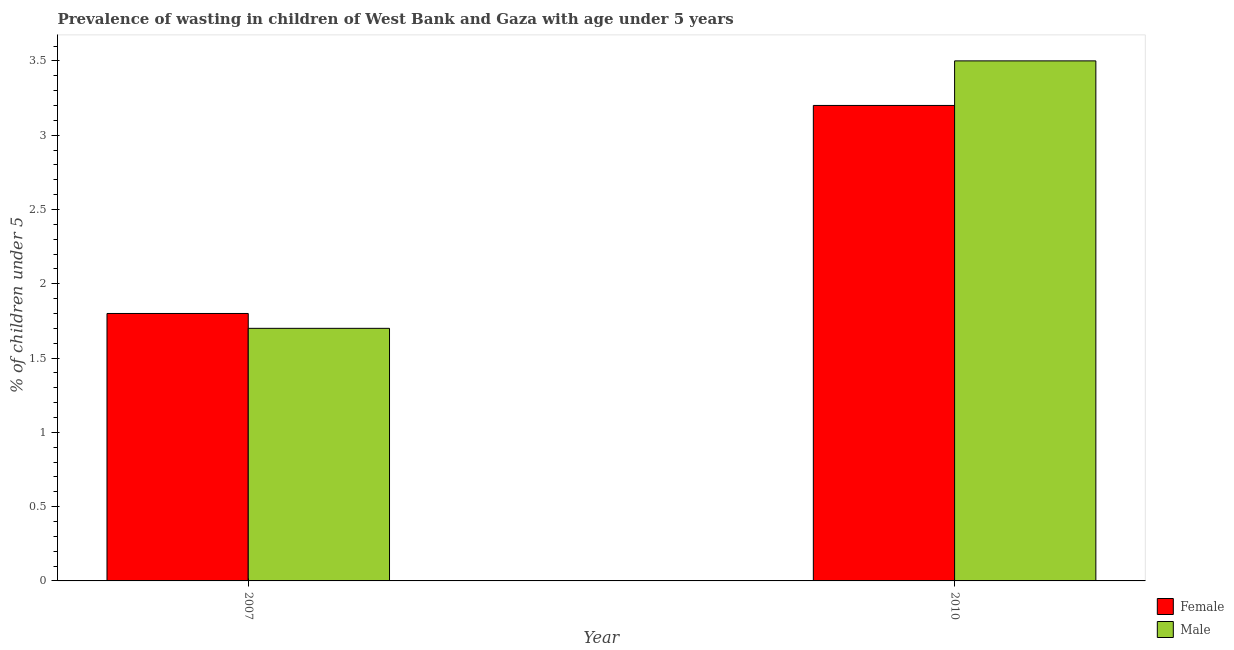How many groups of bars are there?
Your answer should be compact. 2. Are the number of bars per tick equal to the number of legend labels?
Provide a short and direct response. Yes. In how many cases, is the number of bars for a given year not equal to the number of legend labels?
Ensure brevity in your answer.  0. What is the percentage of undernourished male children in 2007?
Give a very brief answer. 1.7. Across all years, what is the maximum percentage of undernourished female children?
Your answer should be very brief. 3.2. Across all years, what is the minimum percentage of undernourished female children?
Offer a very short reply. 1.8. In which year was the percentage of undernourished female children maximum?
Your answer should be compact. 2010. In which year was the percentage of undernourished female children minimum?
Your response must be concise. 2007. What is the total percentage of undernourished male children in the graph?
Your answer should be very brief. 5.2. What is the difference between the percentage of undernourished female children in 2007 and that in 2010?
Ensure brevity in your answer.  -1.4. What is the difference between the percentage of undernourished female children in 2010 and the percentage of undernourished male children in 2007?
Make the answer very short. 1.4. What is the average percentage of undernourished male children per year?
Offer a very short reply. 2.6. In the year 2010, what is the difference between the percentage of undernourished female children and percentage of undernourished male children?
Your answer should be compact. 0. In how many years, is the percentage of undernourished male children greater than 3.5 %?
Your answer should be very brief. 0. What is the ratio of the percentage of undernourished female children in 2007 to that in 2010?
Your response must be concise. 0.56. Is the percentage of undernourished male children in 2007 less than that in 2010?
Keep it short and to the point. Yes. What does the 2nd bar from the left in 2010 represents?
Your answer should be very brief. Male. How many bars are there?
Offer a very short reply. 4. Are all the bars in the graph horizontal?
Provide a succinct answer. No. What is the difference between two consecutive major ticks on the Y-axis?
Your answer should be very brief. 0.5. Are the values on the major ticks of Y-axis written in scientific E-notation?
Offer a terse response. No. Does the graph contain any zero values?
Offer a very short reply. No. Where does the legend appear in the graph?
Your answer should be compact. Bottom right. How are the legend labels stacked?
Provide a succinct answer. Vertical. What is the title of the graph?
Provide a short and direct response. Prevalence of wasting in children of West Bank and Gaza with age under 5 years. Does "Passenger Transport Items" appear as one of the legend labels in the graph?
Ensure brevity in your answer.  No. What is the label or title of the X-axis?
Offer a very short reply. Year. What is the label or title of the Y-axis?
Your answer should be very brief.  % of children under 5. What is the  % of children under 5 of Female in 2007?
Offer a terse response. 1.8. What is the  % of children under 5 in Male in 2007?
Offer a very short reply. 1.7. What is the  % of children under 5 of Female in 2010?
Provide a short and direct response. 3.2. What is the  % of children under 5 in Male in 2010?
Your answer should be very brief. 3.5. Across all years, what is the maximum  % of children under 5 in Female?
Make the answer very short. 3.2. Across all years, what is the maximum  % of children under 5 in Male?
Your answer should be compact. 3.5. Across all years, what is the minimum  % of children under 5 in Female?
Provide a succinct answer. 1.8. Across all years, what is the minimum  % of children under 5 of Male?
Your answer should be compact. 1.7. What is the total  % of children under 5 of Female in the graph?
Your response must be concise. 5. What is the total  % of children under 5 of Male in the graph?
Give a very brief answer. 5.2. What is the difference between the  % of children under 5 of Male in 2007 and that in 2010?
Your answer should be very brief. -1.8. What is the difference between the  % of children under 5 of Female in 2007 and the  % of children under 5 of Male in 2010?
Your answer should be very brief. -1.7. What is the ratio of the  % of children under 5 of Female in 2007 to that in 2010?
Provide a short and direct response. 0.56. What is the ratio of the  % of children under 5 of Male in 2007 to that in 2010?
Your answer should be very brief. 0.49. What is the difference between the highest and the second highest  % of children under 5 in Male?
Provide a short and direct response. 1.8. What is the difference between the highest and the lowest  % of children under 5 in Female?
Your answer should be very brief. 1.4. 